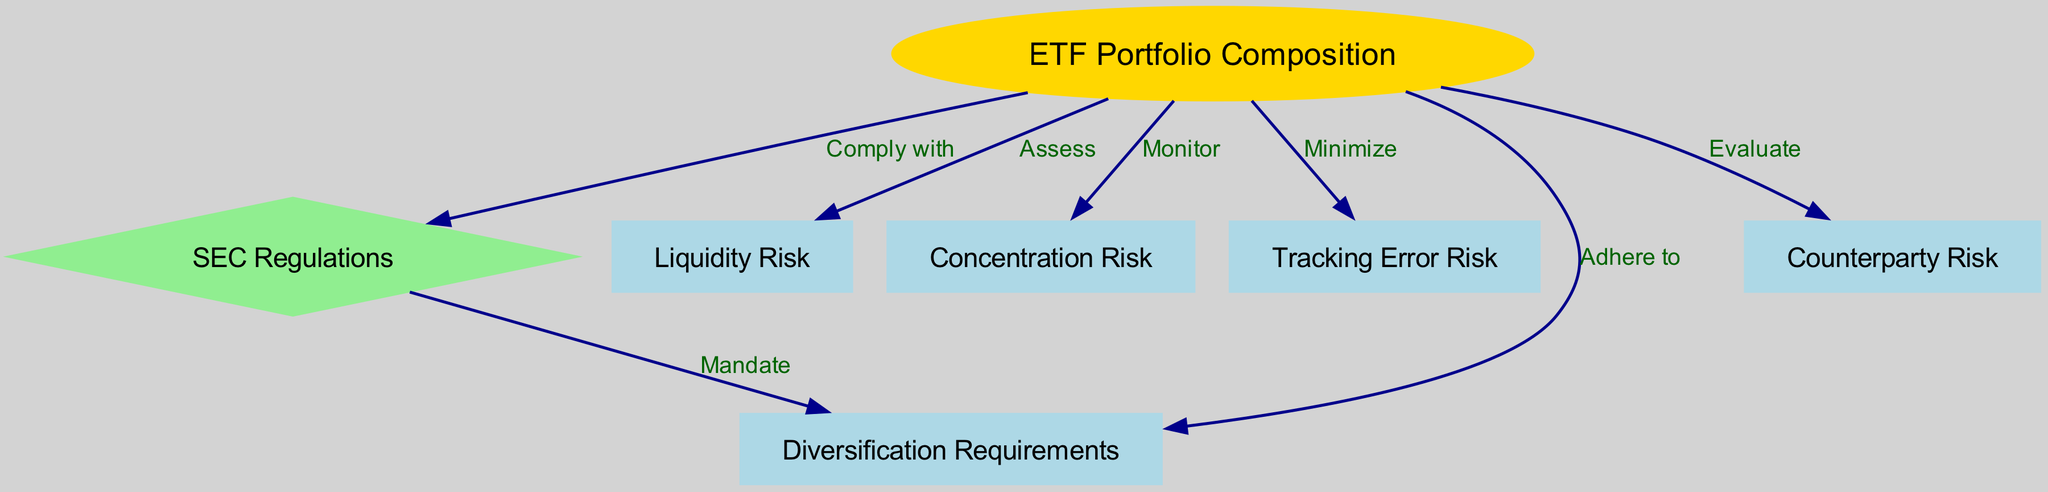What is the core element of the diagram? The core element is represented by node 1, which is labeled "ETF Portfolio Composition." This node serves as the central focus of the compliance risk assessment matrix.
Answer: ETF Portfolio Composition How many nodes are in the diagram? By counting each unique node listed in the data, we find there are 7 nodes in total.
Answer: 7 What type of relationship exists between "ETF Portfolio Composition" and "SEC Regulations"? The relationship is represented by the edge labeled "Comply with," indicating a direct compliance requirement of the ETF's composition with SEC regulations.
Answer: Comply with Which risk is associated with monitoring in the diagram? The diagram indicates that "Concentration Risk" is the risk that is actively monitored as indicated by the edge labeled "Monitor."
Answer: Concentration Risk What must be adhered to according to SEC regulations in the compliance risk assessment? The diagram states that the compliance risk assessment must "Adhere to" the "Diversification Requirements," showing a link to obligations stemming from SEC regulations.
Answer: Diversification Requirements Which risk is assessed related to the ETF portfolio composition? The edge labeled "Assess" associates the action of risk assessment specifically with "Liquidity Risk," indicating this is a key focus area in the risk compliance framework.
Answer: Liquidity Risk What is required to minimize according to the diagram? The diagram highlights that "Tracking Error Risk" needs to be minimized as part of ensuring compliance and efficient portfolio management.
Answer: Tracking Error Risk Which type of risk requires evaluation? The diagram specifies that "Counterparty Risk" is an area identified for evaluation, emphasizing its importance within the compliance risk assessment framework.
Answer: Counterparty Risk What mandate is indicated in relation to SEC regulations and diversification? The diagram shows that SEC regulations impose a "Mandate" concerning "Diversification Requirements," indicating a regulatory need for diversification within ETF portfolios.
Answer: Mandate 